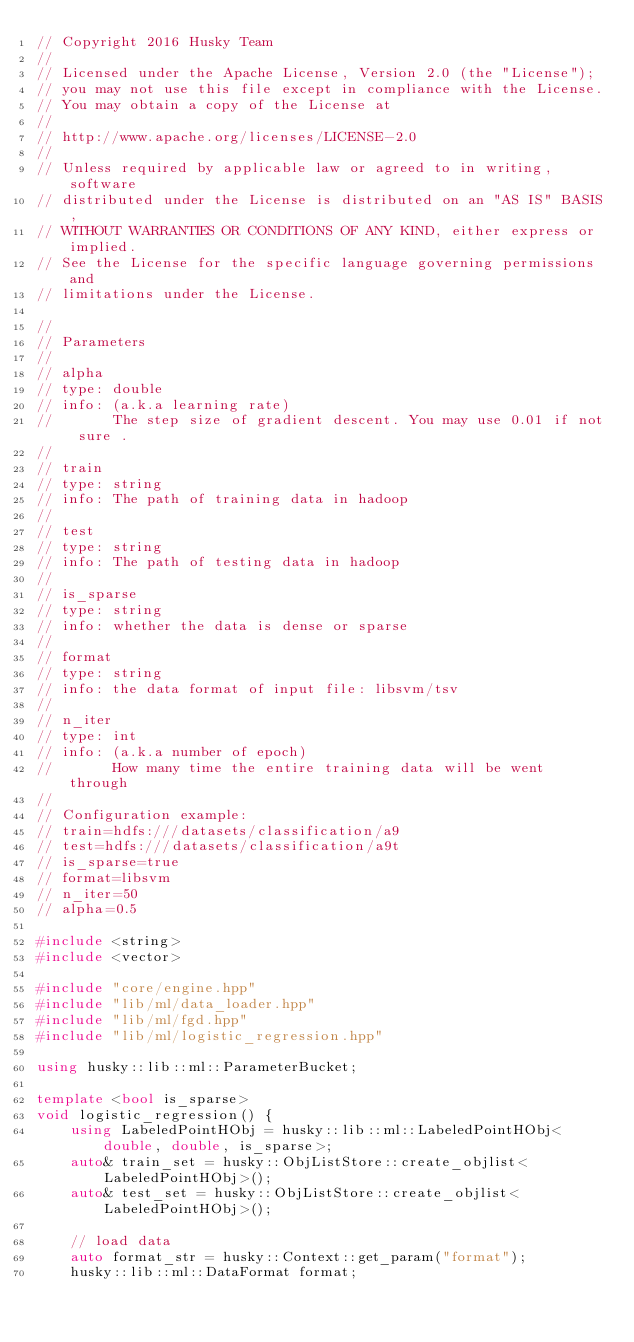Convert code to text. <code><loc_0><loc_0><loc_500><loc_500><_C++_>// Copyright 2016 Husky Team
//
// Licensed under the Apache License, Version 2.0 (the "License");
// you may not use this file except in compliance with the License.
// You may obtain a copy of the License at
//
// http://www.apache.org/licenses/LICENSE-2.0
//
// Unless required by applicable law or agreed to in writing, software
// distributed under the License is distributed on an "AS IS" BASIS,
// WITHOUT WARRANTIES OR CONDITIONS OF ANY KIND, either express or implied.
// See the License for the specific language governing permissions and
// limitations under the License.

//
// Parameters
//
// alpha
// type: double
// info: (a.k.a learning rate)
//       The step size of gradient descent. You may use 0.01 if not sure .
//
// train
// type: string
// info: The path of training data in hadoop
//
// test
// type: string
// info: The path of testing data in hadoop
//
// is_sparse
// type: string
// info: whether the data is dense or sparse
//
// format
// type: string
// info: the data format of input file: libsvm/tsv
//
// n_iter
// type: int
// info: (a.k.a number of epoch)
//       How many time the entire training data will be went through
//
// Configuration example:
// train=hdfs:///datasets/classification/a9
// test=hdfs:///datasets/classification/a9t
// is_sparse=true
// format=libsvm
// n_iter=50
// alpha=0.5

#include <string>
#include <vector>

#include "core/engine.hpp"
#include "lib/ml/data_loader.hpp"
#include "lib/ml/fgd.hpp"
#include "lib/ml/logistic_regression.hpp"

using husky::lib::ml::ParameterBucket;

template <bool is_sparse>
void logistic_regression() {
    using LabeledPointHObj = husky::lib::ml::LabeledPointHObj<double, double, is_sparse>;
    auto& train_set = husky::ObjListStore::create_objlist<LabeledPointHObj>();
    auto& test_set = husky::ObjListStore::create_objlist<LabeledPointHObj>();

    // load data
    auto format_str = husky::Context::get_param("format");
    husky::lib::ml::DataFormat format;</code> 